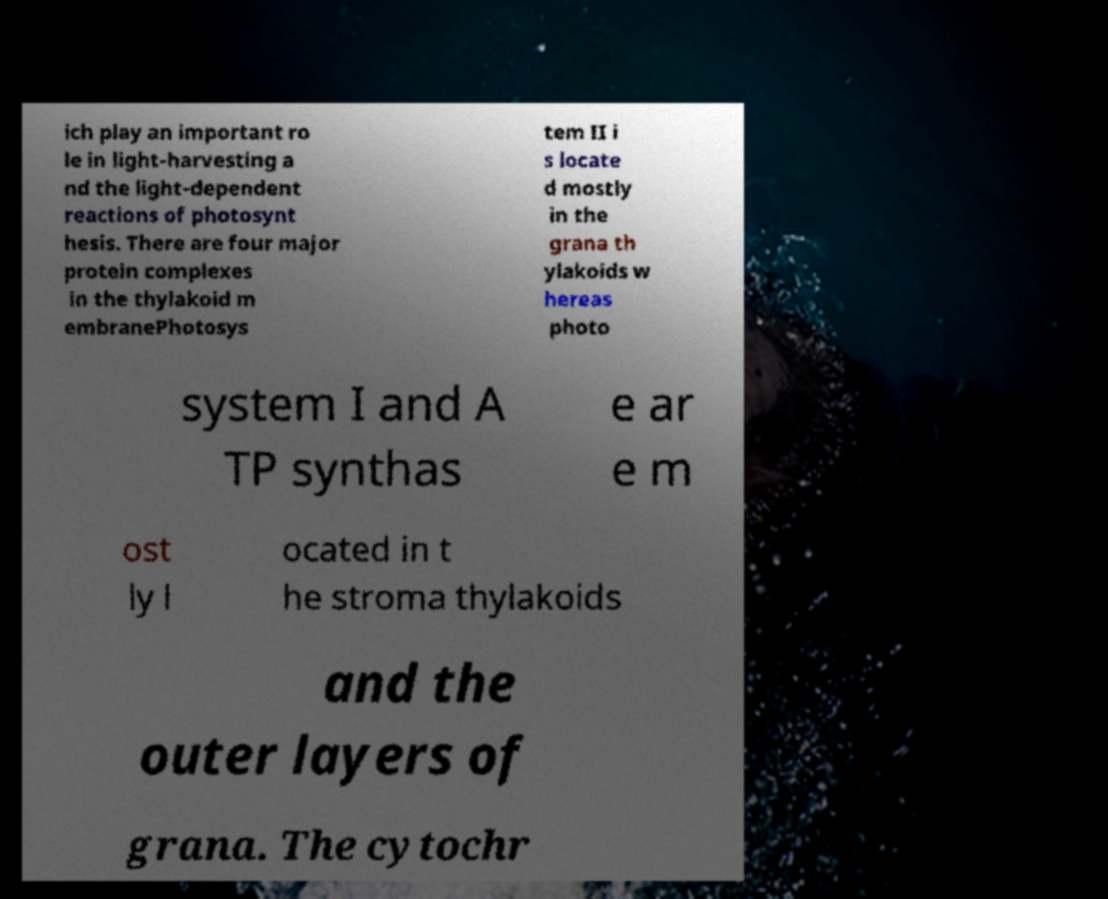Could you extract and type out the text from this image? ich play an important ro le in light-harvesting a nd the light-dependent reactions of photosynt hesis. There are four major protein complexes in the thylakoid m embranePhotosys tem II i s locate d mostly in the grana th ylakoids w hereas photo system I and A TP synthas e ar e m ost ly l ocated in t he stroma thylakoids and the outer layers of grana. The cytochr 